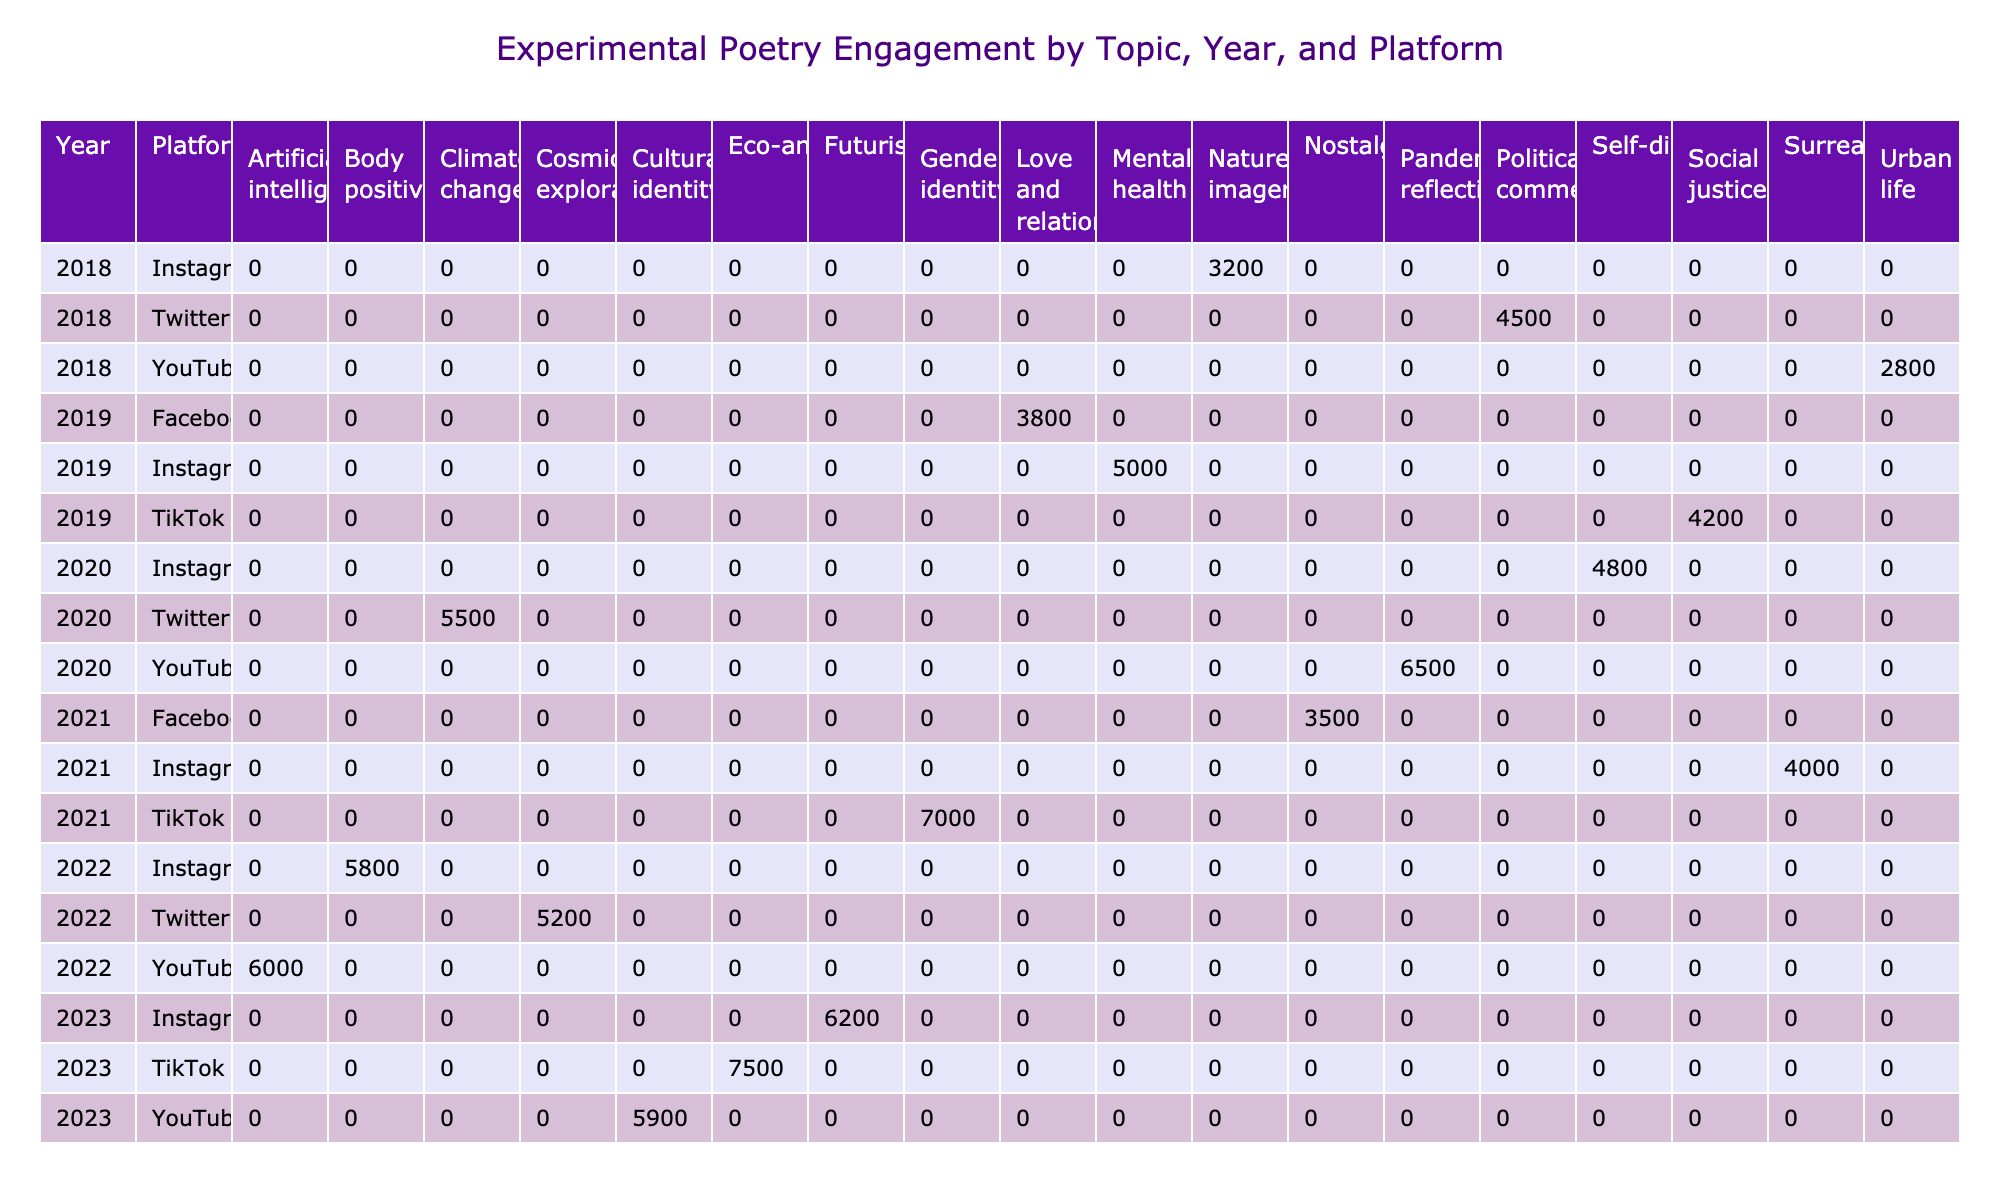What was the highest engagement for a topic in the year 2020? In the year 2020, we check the engagement values for all topics. The topic "Pandemic reflections" on YouTube had the highest engagement, which was 6500.
Answer: 6500 Which platform had more engagement in 2021: Instagram or TikTok? For the year 2021, we compare the engagement values for Instagram (4000) and TikTok (7000). TikTok had higher engagement than Instagram.
Answer: TikTok had more engagement What is the average engagement across all topics for the year 2019? The engagement values for 2019 are 5000, 3800, and 4200. Summing these values gives 5000 + 3800 + 4200 = 13000. There are 3 data points, so the average is 13000 / 3 ≈ 4333.33.
Answer: Approximately 4333.33 Did the topic "Social justice" receive more shares or views on TikTok in 2019? For the topic "Social justice" on TikTok in 2019, the data indicates 4200 shares and 30000 views. Since 30000 is greater than 4200, it had more views than shares.
Answer: Yes, it had more views In which year did "Eco-anxiety" receive the most engagement on TikTok? The data shows that "Eco-anxiety" was only listed in 2023 on TikTok, with an engagement value of 7500, which is the highest engagement for that topic in comparison to other years' entries.
Answer: 2023 